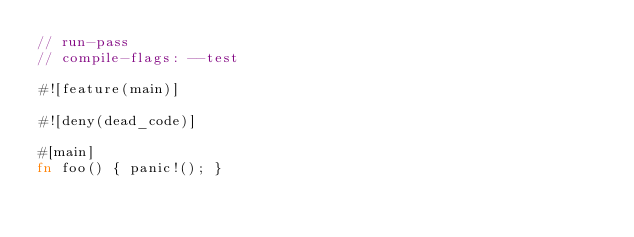<code> <loc_0><loc_0><loc_500><loc_500><_Rust_>// run-pass
// compile-flags: --test

#![feature(main)]

#![deny(dead_code)]

#[main]
fn foo() { panic!(); }
</code> 